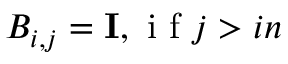Convert formula to latex. <formula><loc_0><loc_0><loc_500><loc_500>B _ { i , j } = I , i f j > i n</formula> 